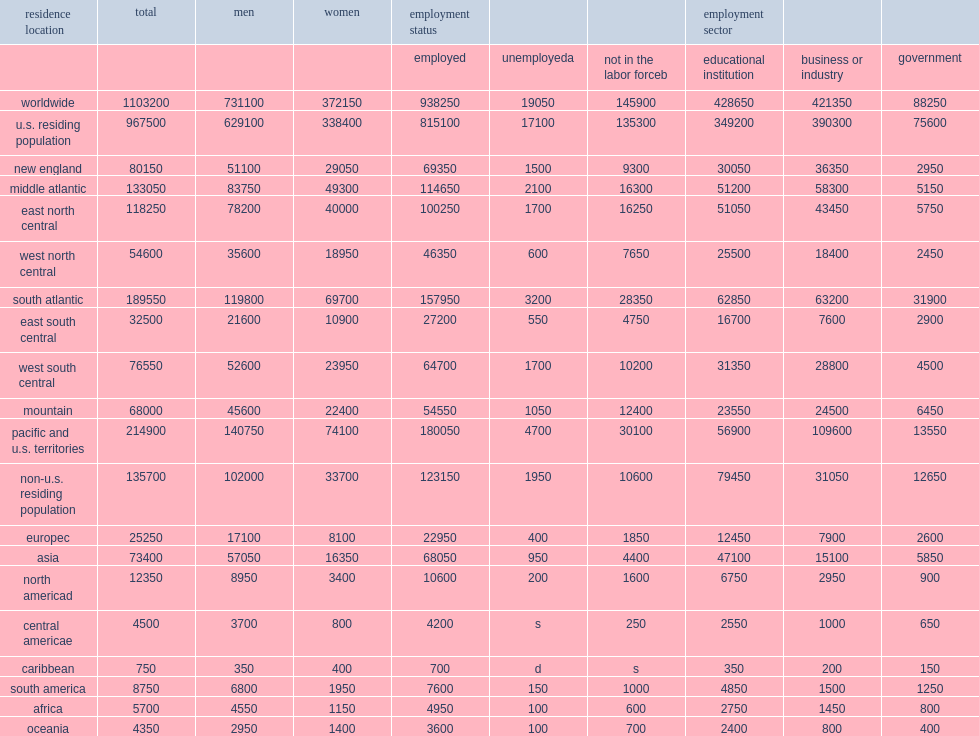In 2017, how many individuals worldwide held a research doctoral degree in a science, engineering, or health (seh) field? 1103200.0. How many individuals were residing in the united states? 967500.0. How many percent of individuals residing in the united states were women? 0.349767. How many individuals residing in the united states were women? 338400.0. How many individuals were living abroad? 135700.0. An additional 135,700 were living abroad, how many percent of whom were women? 0.248342. 